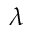<formula> <loc_0><loc_0><loc_500><loc_500>\lambda</formula> 